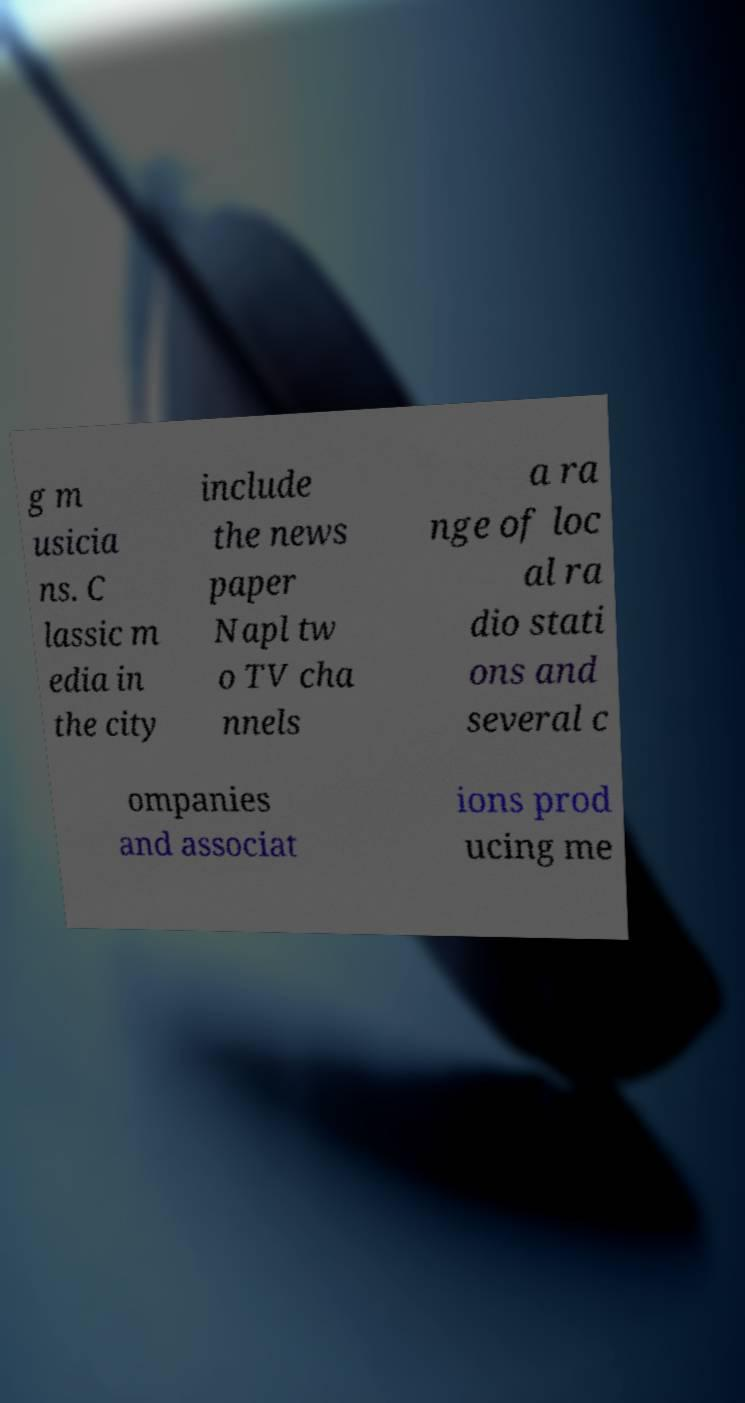Please read and relay the text visible in this image. What does it say? g m usicia ns. C lassic m edia in the city include the news paper Napl tw o TV cha nnels a ra nge of loc al ra dio stati ons and several c ompanies and associat ions prod ucing me 